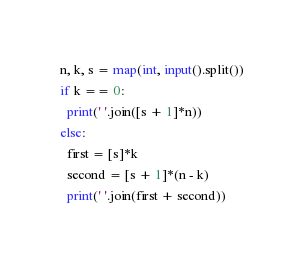Convert code to text. <code><loc_0><loc_0><loc_500><loc_500><_Python_>n, k, s = map(int, input().split())
if k == 0:
  print(' '.join([s + 1]*n))
else:
  first = [s]*k
  second = [s + 1]*(n - k)
  print(' '.join(first + second))</code> 